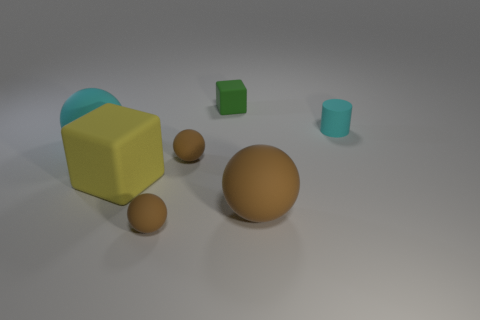Subtract all purple cylinders. How many brown balls are left? 3 Add 3 gray metal objects. How many objects exist? 10 Subtract all cylinders. How many objects are left? 6 Subtract all large yellow things. Subtract all big brown things. How many objects are left? 5 Add 7 large cyan balls. How many large cyan balls are left? 8 Add 4 small cyan rubber cylinders. How many small cyan rubber cylinders exist? 5 Subtract 0 yellow balls. How many objects are left? 7 